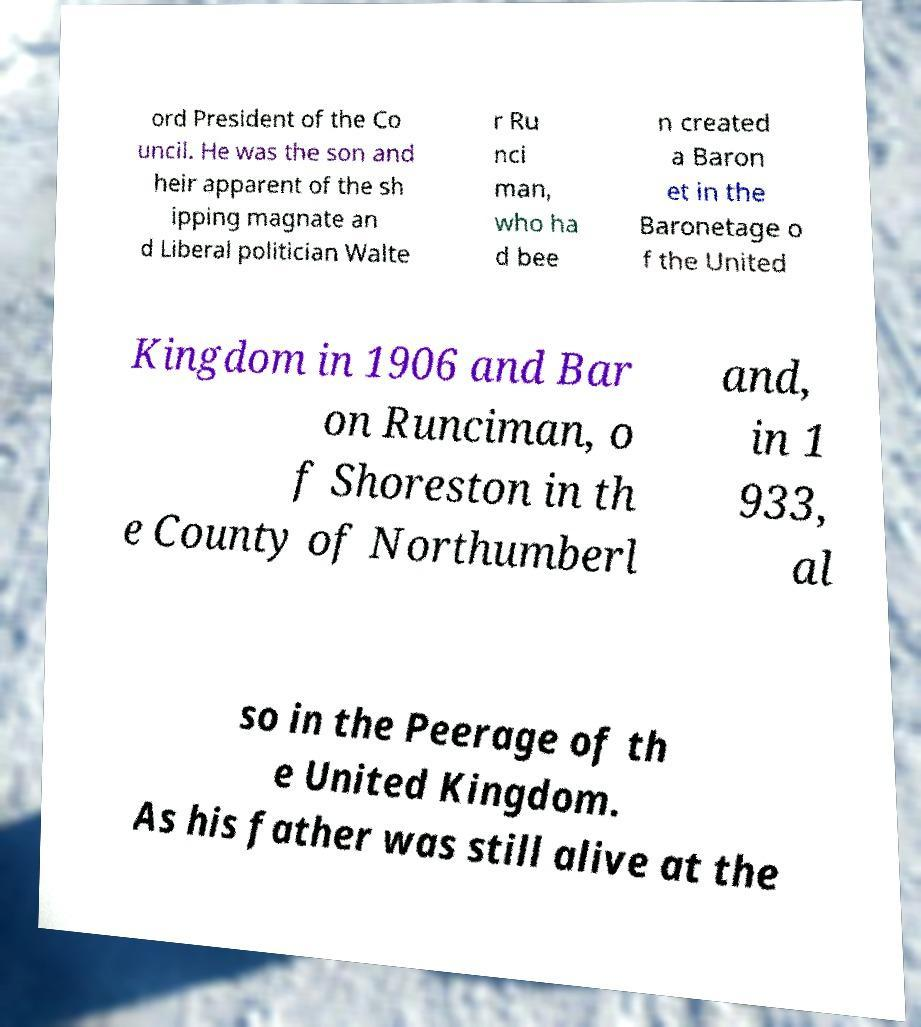Can you accurately transcribe the text from the provided image for me? ord President of the Co uncil. He was the son and heir apparent of the sh ipping magnate an d Liberal politician Walte r Ru nci man, who ha d bee n created a Baron et in the Baronetage o f the United Kingdom in 1906 and Bar on Runciman, o f Shoreston in th e County of Northumberl and, in 1 933, al so in the Peerage of th e United Kingdom. As his father was still alive at the 